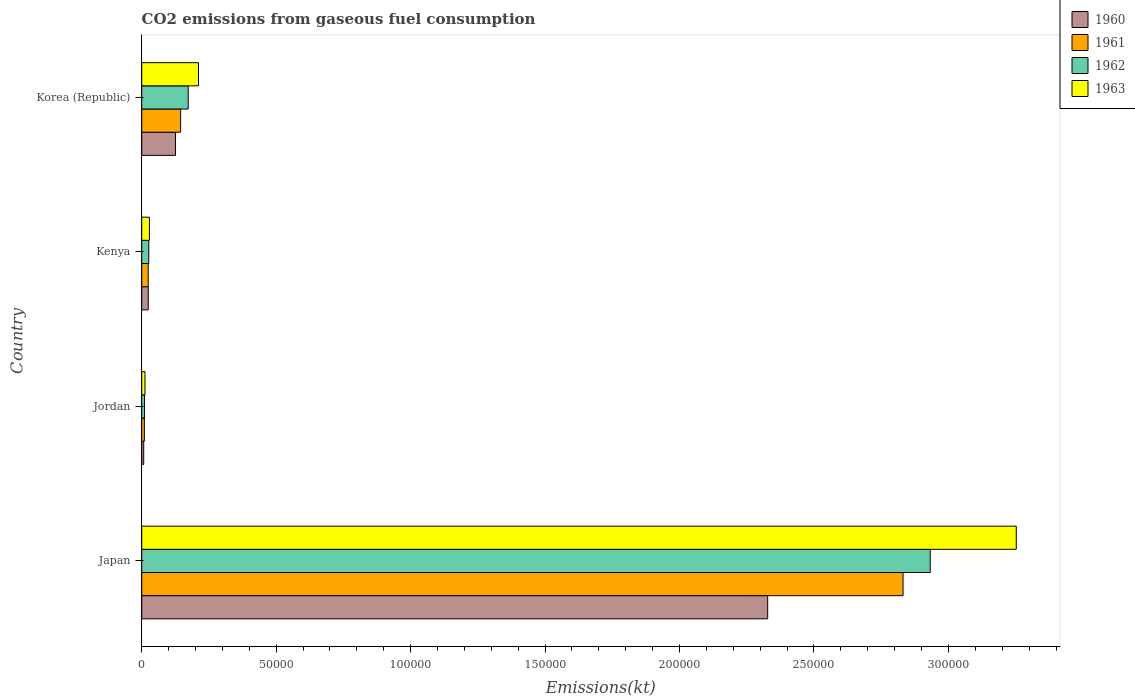How many different coloured bars are there?
Offer a terse response. 4. How many groups of bars are there?
Make the answer very short. 4. How many bars are there on the 1st tick from the bottom?
Ensure brevity in your answer.  4. What is the label of the 2nd group of bars from the top?
Offer a terse response. Kenya. In how many cases, is the number of bars for a given country not equal to the number of legend labels?
Offer a very short reply. 0. What is the amount of CO2 emitted in 1961 in Japan?
Your answer should be very brief. 2.83e+05. Across all countries, what is the maximum amount of CO2 emitted in 1960?
Your answer should be very brief. 2.33e+05. Across all countries, what is the minimum amount of CO2 emitted in 1962?
Provide a succinct answer. 1048.76. In which country was the amount of CO2 emitted in 1960 maximum?
Keep it short and to the point. Japan. In which country was the amount of CO2 emitted in 1962 minimum?
Ensure brevity in your answer.  Jordan. What is the total amount of CO2 emitted in 1960 in the graph?
Your answer should be very brief. 2.49e+05. What is the difference between the amount of CO2 emitted in 1963 in Kenya and that in Korea (Republic)?
Give a very brief answer. -1.82e+04. What is the difference between the amount of CO2 emitted in 1961 in Japan and the amount of CO2 emitted in 1960 in Korea (Republic)?
Your answer should be compact. 2.71e+05. What is the average amount of CO2 emitted in 1960 per country?
Make the answer very short. 6.21e+04. What is the difference between the amount of CO2 emitted in 1962 and amount of CO2 emitted in 1961 in Japan?
Give a very brief answer. 1.01e+04. In how many countries, is the amount of CO2 emitted in 1962 greater than 110000 kt?
Your response must be concise. 1. What is the ratio of the amount of CO2 emitted in 1962 in Jordan to that in Kenya?
Ensure brevity in your answer.  0.4. Is the amount of CO2 emitted in 1961 in Japan less than that in Jordan?
Offer a very short reply. No. What is the difference between the highest and the second highest amount of CO2 emitted in 1960?
Ensure brevity in your answer.  2.20e+05. What is the difference between the highest and the lowest amount of CO2 emitted in 1962?
Your answer should be compact. 2.92e+05. In how many countries, is the amount of CO2 emitted in 1962 greater than the average amount of CO2 emitted in 1962 taken over all countries?
Provide a short and direct response. 1. Is it the case that in every country, the sum of the amount of CO2 emitted in 1961 and amount of CO2 emitted in 1963 is greater than the sum of amount of CO2 emitted in 1962 and amount of CO2 emitted in 1960?
Give a very brief answer. No. Is it the case that in every country, the sum of the amount of CO2 emitted in 1960 and amount of CO2 emitted in 1961 is greater than the amount of CO2 emitted in 1962?
Your answer should be compact. Yes. Are all the bars in the graph horizontal?
Offer a terse response. Yes. What is the difference between two consecutive major ticks on the X-axis?
Your answer should be compact. 5.00e+04. Are the values on the major ticks of X-axis written in scientific E-notation?
Offer a very short reply. No. Does the graph contain any zero values?
Offer a terse response. No. Does the graph contain grids?
Make the answer very short. No. Where does the legend appear in the graph?
Offer a very short reply. Top right. What is the title of the graph?
Offer a terse response. CO2 emissions from gaseous fuel consumption. Does "1969" appear as one of the legend labels in the graph?
Provide a short and direct response. No. What is the label or title of the X-axis?
Your answer should be compact. Emissions(kt). What is the label or title of the Y-axis?
Your answer should be compact. Country. What is the Emissions(kt) in 1960 in Japan?
Offer a very short reply. 2.33e+05. What is the Emissions(kt) of 1961 in Japan?
Ensure brevity in your answer.  2.83e+05. What is the Emissions(kt) in 1962 in Japan?
Keep it short and to the point. 2.93e+05. What is the Emissions(kt) of 1963 in Japan?
Provide a short and direct response. 3.25e+05. What is the Emissions(kt) of 1960 in Jordan?
Your answer should be very brief. 744.4. What is the Emissions(kt) of 1961 in Jordan?
Offer a very short reply. 979.09. What is the Emissions(kt) in 1962 in Jordan?
Provide a succinct answer. 1048.76. What is the Emissions(kt) of 1963 in Jordan?
Your answer should be very brief. 1221.11. What is the Emissions(kt) in 1960 in Kenya?
Offer a terse response. 2427.55. What is the Emissions(kt) in 1961 in Kenya?
Your answer should be very brief. 2401.89. What is the Emissions(kt) in 1962 in Kenya?
Your answer should be very brief. 2625.57. What is the Emissions(kt) of 1963 in Kenya?
Offer a very short reply. 2856.59. What is the Emissions(kt) of 1960 in Korea (Republic)?
Ensure brevity in your answer.  1.26e+04. What is the Emissions(kt) in 1961 in Korea (Republic)?
Give a very brief answer. 1.45e+04. What is the Emissions(kt) in 1962 in Korea (Republic)?
Ensure brevity in your answer.  1.73e+04. What is the Emissions(kt) of 1963 in Korea (Republic)?
Provide a short and direct response. 2.11e+04. Across all countries, what is the maximum Emissions(kt) in 1960?
Offer a terse response. 2.33e+05. Across all countries, what is the maximum Emissions(kt) of 1961?
Keep it short and to the point. 2.83e+05. Across all countries, what is the maximum Emissions(kt) in 1962?
Provide a succinct answer. 2.93e+05. Across all countries, what is the maximum Emissions(kt) in 1963?
Make the answer very short. 3.25e+05. Across all countries, what is the minimum Emissions(kt) of 1960?
Offer a very short reply. 744.4. Across all countries, what is the minimum Emissions(kt) in 1961?
Offer a very short reply. 979.09. Across all countries, what is the minimum Emissions(kt) in 1962?
Provide a succinct answer. 1048.76. Across all countries, what is the minimum Emissions(kt) of 1963?
Give a very brief answer. 1221.11. What is the total Emissions(kt) in 1960 in the graph?
Your response must be concise. 2.49e+05. What is the total Emissions(kt) of 1961 in the graph?
Provide a short and direct response. 3.01e+05. What is the total Emissions(kt) of 1962 in the graph?
Your response must be concise. 3.14e+05. What is the total Emissions(kt) in 1963 in the graph?
Offer a terse response. 3.50e+05. What is the difference between the Emissions(kt) in 1960 in Japan and that in Jordan?
Provide a succinct answer. 2.32e+05. What is the difference between the Emissions(kt) of 1961 in Japan and that in Jordan?
Ensure brevity in your answer.  2.82e+05. What is the difference between the Emissions(kt) in 1962 in Japan and that in Jordan?
Keep it short and to the point. 2.92e+05. What is the difference between the Emissions(kt) in 1963 in Japan and that in Jordan?
Offer a very short reply. 3.24e+05. What is the difference between the Emissions(kt) of 1960 in Japan and that in Kenya?
Offer a terse response. 2.30e+05. What is the difference between the Emissions(kt) of 1961 in Japan and that in Kenya?
Offer a very short reply. 2.81e+05. What is the difference between the Emissions(kt) in 1962 in Japan and that in Kenya?
Offer a very short reply. 2.91e+05. What is the difference between the Emissions(kt) of 1963 in Japan and that in Kenya?
Your response must be concise. 3.22e+05. What is the difference between the Emissions(kt) in 1960 in Japan and that in Korea (Republic)?
Give a very brief answer. 2.20e+05. What is the difference between the Emissions(kt) of 1961 in Japan and that in Korea (Republic)?
Keep it short and to the point. 2.69e+05. What is the difference between the Emissions(kt) of 1962 in Japan and that in Korea (Republic)?
Make the answer very short. 2.76e+05. What is the difference between the Emissions(kt) in 1963 in Japan and that in Korea (Republic)?
Provide a succinct answer. 3.04e+05. What is the difference between the Emissions(kt) of 1960 in Jordan and that in Kenya?
Offer a terse response. -1683.15. What is the difference between the Emissions(kt) of 1961 in Jordan and that in Kenya?
Provide a short and direct response. -1422.8. What is the difference between the Emissions(kt) of 1962 in Jordan and that in Kenya?
Make the answer very short. -1576.81. What is the difference between the Emissions(kt) of 1963 in Jordan and that in Kenya?
Your answer should be compact. -1635.48. What is the difference between the Emissions(kt) in 1960 in Jordan and that in Korea (Republic)?
Give a very brief answer. -1.18e+04. What is the difference between the Emissions(kt) of 1961 in Jordan and that in Korea (Republic)?
Your response must be concise. -1.35e+04. What is the difference between the Emissions(kt) in 1962 in Jordan and that in Korea (Republic)?
Your response must be concise. -1.62e+04. What is the difference between the Emissions(kt) in 1963 in Jordan and that in Korea (Republic)?
Offer a very short reply. -1.99e+04. What is the difference between the Emissions(kt) in 1960 in Kenya and that in Korea (Republic)?
Provide a short and direct response. -1.01e+04. What is the difference between the Emissions(kt) in 1961 in Kenya and that in Korea (Republic)?
Offer a very short reply. -1.21e+04. What is the difference between the Emissions(kt) of 1962 in Kenya and that in Korea (Republic)?
Make the answer very short. -1.47e+04. What is the difference between the Emissions(kt) in 1963 in Kenya and that in Korea (Republic)?
Ensure brevity in your answer.  -1.82e+04. What is the difference between the Emissions(kt) in 1960 in Japan and the Emissions(kt) in 1961 in Jordan?
Keep it short and to the point. 2.32e+05. What is the difference between the Emissions(kt) of 1960 in Japan and the Emissions(kt) of 1962 in Jordan?
Keep it short and to the point. 2.32e+05. What is the difference between the Emissions(kt) of 1960 in Japan and the Emissions(kt) of 1963 in Jordan?
Give a very brief answer. 2.32e+05. What is the difference between the Emissions(kt) in 1961 in Japan and the Emissions(kt) in 1962 in Jordan?
Give a very brief answer. 2.82e+05. What is the difference between the Emissions(kt) in 1961 in Japan and the Emissions(kt) in 1963 in Jordan?
Your answer should be very brief. 2.82e+05. What is the difference between the Emissions(kt) in 1962 in Japan and the Emissions(kt) in 1963 in Jordan?
Ensure brevity in your answer.  2.92e+05. What is the difference between the Emissions(kt) in 1960 in Japan and the Emissions(kt) in 1961 in Kenya?
Offer a very short reply. 2.30e+05. What is the difference between the Emissions(kt) in 1960 in Japan and the Emissions(kt) in 1962 in Kenya?
Your answer should be compact. 2.30e+05. What is the difference between the Emissions(kt) in 1960 in Japan and the Emissions(kt) in 1963 in Kenya?
Provide a short and direct response. 2.30e+05. What is the difference between the Emissions(kt) in 1961 in Japan and the Emissions(kt) in 1962 in Kenya?
Offer a terse response. 2.80e+05. What is the difference between the Emissions(kt) in 1961 in Japan and the Emissions(kt) in 1963 in Kenya?
Your response must be concise. 2.80e+05. What is the difference between the Emissions(kt) in 1962 in Japan and the Emissions(kt) in 1963 in Kenya?
Your response must be concise. 2.90e+05. What is the difference between the Emissions(kt) of 1960 in Japan and the Emissions(kt) of 1961 in Korea (Republic)?
Your response must be concise. 2.18e+05. What is the difference between the Emissions(kt) in 1960 in Japan and the Emissions(kt) in 1962 in Korea (Republic)?
Provide a short and direct response. 2.16e+05. What is the difference between the Emissions(kt) in 1960 in Japan and the Emissions(kt) in 1963 in Korea (Republic)?
Provide a short and direct response. 2.12e+05. What is the difference between the Emissions(kt) in 1961 in Japan and the Emissions(kt) in 1962 in Korea (Republic)?
Your answer should be very brief. 2.66e+05. What is the difference between the Emissions(kt) in 1961 in Japan and the Emissions(kt) in 1963 in Korea (Republic)?
Your answer should be very brief. 2.62e+05. What is the difference between the Emissions(kt) of 1962 in Japan and the Emissions(kt) of 1963 in Korea (Republic)?
Make the answer very short. 2.72e+05. What is the difference between the Emissions(kt) in 1960 in Jordan and the Emissions(kt) in 1961 in Kenya?
Your answer should be very brief. -1657.48. What is the difference between the Emissions(kt) of 1960 in Jordan and the Emissions(kt) of 1962 in Kenya?
Offer a very short reply. -1881.17. What is the difference between the Emissions(kt) in 1960 in Jordan and the Emissions(kt) in 1963 in Kenya?
Provide a succinct answer. -2112.19. What is the difference between the Emissions(kt) in 1961 in Jordan and the Emissions(kt) in 1962 in Kenya?
Offer a very short reply. -1646.48. What is the difference between the Emissions(kt) in 1961 in Jordan and the Emissions(kt) in 1963 in Kenya?
Your answer should be very brief. -1877.5. What is the difference between the Emissions(kt) in 1962 in Jordan and the Emissions(kt) in 1963 in Kenya?
Your response must be concise. -1807.83. What is the difference between the Emissions(kt) in 1960 in Jordan and the Emissions(kt) in 1961 in Korea (Republic)?
Ensure brevity in your answer.  -1.37e+04. What is the difference between the Emissions(kt) in 1960 in Jordan and the Emissions(kt) in 1962 in Korea (Republic)?
Provide a succinct answer. -1.65e+04. What is the difference between the Emissions(kt) in 1960 in Jordan and the Emissions(kt) in 1963 in Korea (Republic)?
Keep it short and to the point. -2.04e+04. What is the difference between the Emissions(kt) of 1961 in Jordan and the Emissions(kt) of 1962 in Korea (Republic)?
Make the answer very short. -1.63e+04. What is the difference between the Emissions(kt) in 1961 in Jordan and the Emissions(kt) in 1963 in Korea (Republic)?
Make the answer very short. -2.01e+04. What is the difference between the Emissions(kt) of 1962 in Jordan and the Emissions(kt) of 1963 in Korea (Republic)?
Give a very brief answer. -2.01e+04. What is the difference between the Emissions(kt) of 1960 in Kenya and the Emissions(kt) of 1961 in Korea (Republic)?
Your answer should be very brief. -1.20e+04. What is the difference between the Emissions(kt) of 1960 in Kenya and the Emissions(kt) of 1962 in Korea (Republic)?
Offer a very short reply. -1.49e+04. What is the difference between the Emissions(kt) of 1960 in Kenya and the Emissions(kt) of 1963 in Korea (Republic)?
Your answer should be very brief. -1.87e+04. What is the difference between the Emissions(kt) in 1961 in Kenya and the Emissions(kt) in 1962 in Korea (Republic)?
Provide a succinct answer. -1.49e+04. What is the difference between the Emissions(kt) of 1961 in Kenya and the Emissions(kt) of 1963 in Korea (Republic)?
Your answer should be compact. -1.87e+04. What is the difference between the Emissions(kt) in 1962 in Kenya and the Emissions(kt) in 1963 in Korea (Republic)?
Offer a terse response. -1.85e+04. What is the average Emissions(kt) in 1960 per country?
Your response must be concise. 6.21e+04. What is the average Emissions(kt) in 1961 per country?
Your answer should be compact. 7.52e+04. What is the average Emissions(kt) in 1962 per country?
Make the answer very short. 7.85e+04. What is the average Emissions(kt) in 1963 per country?
Give a very brief answer. 8.76e+04. What is the difference between the Emissions(kt) in 1960 and Emissions(kt) in 1961 in Japan?
Provide a short and direct response. -5.03e+04. What is the difference between the Emissions(kt) in 1960 and Emissions(kt) in 1962 in Japan?
Offer a very short reply. -6.04e+04. What is the difference between the Emissions(kt) in 1960 and Emissions(kt) in 1963 in Japan?
Ensure brevity in your answer.  -9.24e+04. What is the difference between the Emissions(kt) of 1961 and Emissions(kt) of 1962 in Japan?
Offer a terse response. -1.01e+04. What is the difference between the Emissions(kt) of 1961 and Emissions(kt) of 1963 in Japan?
Provide a short and direct response. -4.21e+04. What is the difference between the Emissions(kt) of 1962 and Emissions(kt) of 1963 in Japan?
Make the answer very short. -3.20e+04. What is the difference between the Emissions(kt) of 1960 and Emissions(kt) of 1961 in Jordan?
Make the answer very short. -234.69. What is the difference between the Emissions(kt) of 1960 and Emissions(kt) of 1962 in Jordan?
Keep it short and to the point. -304.36. What is the difference between the Emissions(kt) in 1960 and Emissions(kt) in 1963 in Jordan?
Your answer should be very brief. -476.71. What is the difference between the Emissions(kt) of 1961 and Emissions(kt) of 1962 in Jordan?
Provide a succinct answer. -69.67. What is the difference between the Emissions(kt) of 1961 and Emissions(kt) of 1963 in Jordan?
Make the answer very short. -242.02. What is the difference between the Emissions(kt) in 1962 and Emissions(kt) in 1963 in Jordan?
Your answer should be very brief. -172.35. What is the difference between the Emissions(kt) in 1960 and Emissions(kt) in 1961 in Kenya?
Give a very brief answer. 25.67. What is the difference between the Emissions(kt) in 1960 and Emissions(kt) in 1962 in Kenya?
Offer a terse response. -198.02. What is the difference between the Emissions(kt) of 1960 and Emissions(kt) of 1963 in Kenya?
Provide a succinct answer. -429.04. What is the difference between the Emissions(kt) of 1961 and Emissions(kt) of 1962 in Kenya?
Make the answer very short. -223.69. What is the difference between the Emissions(kt) in 1961 and Emissions(kt) in 1963 in Kenya?
Your answer should be compact. -454.71. What is the difference between the Emissions(kt) of 1962 and Emissions(kt) of 1963 in Kenya?
Offer a terse response. -231.02. What is the difference between the Emissions(kt) in 1960 and Emissions(kt) in 1961 in Korea (Republic)?
Make the answer very short. -1910.51. What is the difference between the Emissions(kt) in 1960 and Emissions(kt) in 1962 in Korea (Republic)?
Provide a short and direct response. -4726.76. What is the difference between the Emissions(kt) of 1960 and Emissions(kt) of 1963 in Korea (Republic)?
Provide a short and direct response. -8551.44. What is the difference between the Emissions(kt) in 1961 and Emissions(kt) in 1962 in Korea (Republic)?
Your response must be concise. -2816.26. What is the difference between the Emissions(kt) in 1961 and Emissions(kt) in 1963 in Korea (Republic)?
Ensure brevity in your answer.  -6640.94. What is the difference between the Emissions(kt) in 1962 and Emissions(kt) in 1963 in Korea (Republic)?
Ensure brevity in your answer.  -3824.68. What is the ratio of the Emissions(kt) of 1960 in Japan to that in Jordan?
Your answer should be compact. 312.71. What is the ratio of the Emissions(kt) in 1961 in Japan to that in Jordan?
Make the answer very short. 289.16. What is the ratio of the Emissions(kt) of 1962 in Japan to that in Jordan?
Your response must be concise. 279.59. What is the ratio of the Emissions(kt) in 1963 in Japan to that in Jordan?
Keep it short and to the point. 266.33. What is the ratio of the Emissions(kt) of 1960 in Japan to that in Kenya?
Your response must be concise. 95.89. What is the ratio of the Emissions(kt) of 1961 in Japan to that in Kenya?
Your response must be concise. 117.87. What is the ratio of the Emissions(kt) of 1962 in Japan to that in Kenya?
Provide a short and direct response. 111.68. What is the ratio of the Emissions(kt) in 1963 in Japan to that in Kenya?
Give a very brief answer. 113.85. What is the ratio of the Emissions(kt) in 1960 in Japan to that in Korea (Republic)?
Keep it short and to the point. 18.55. What is the ratio of the Emissions(kt) of 1961 in Japan to that in Korea (Republic)?
Your answer should be compact. 19.58. What is the ratio of the Emissions(kt) in 1962 in Japan to that in Korea (Republic)?
Make the answer very short. 16.97. What is the ratio of the Emissions(kt) of 1963 in Japan to that in Korea (Republic)?
Give a very brief answer. 15.41. What is the ratio of the Emissions(kt) in 1960 in Jordan to that in Kenya?
Provide a short and direct response. 0.31. What is the ratio of the Emissions(kt) in 1961 in Jordan to that in Kenya?
Offer a terse response. 0.41. What is the ratio of the Emissions(kt) in 1962 in Jordan to that in Kenya?
Ensure brevity in your answer.  0.4. What is the ratio of the Emissions(kt) in 1963 in Jordan to that in Kenya?
Your answer should be compact. 0.43. What is the ratio of the Emissions(kt) in 1960 in Jordan to that in Korea (Republic)?
Your answer should be very brief. 0.06. What is the ratio of the Emissions(kt) in 1961 in Jordan to that in Korea (Republic)?
Give a very brief answer. 0.07. What is the ratio of the Emissions(kt) of 1962 in Jordan to that in Korea (Republic)?
Ensure brevity in your answer.  0.06. What is the ratio of the Emissions(kt) in 1963 in Jordan to that in Korea (Republic)?
Provide a succinct answer. 0.06. What is the ratio of the Emissions(kt) in 1960 in Kenya to that in Korea (Republic)?
Give a very brief answer. 0.19. What is the ratio of the Emissions(kt) of 1961 in Kenya to that in Korea (Republic)?
Keep it short and to the point. 0.17. What is the ratio of the Emissions(kt) in 1962 in Kenya to that in Korea (Republic)?
Provide a succinct answer. 0.15. What is the ratio of the Emissions(kt) of 1963 in Kenya to that in Korea (Republic)?
Your response must be concise. 0.14. What is the difference between the highest and the second highest Emissions(kt) in 1960?
Your answer should be compact. 2.20e+05. What is the difference between the highest and the second highest Emissions(kt) of 1961?
Offer a very short reply. 2.69e+05. What is the difference between the highest and the second highest Emissions(kt) of 1962?
Keep it short and to the point. 2.76e+05. What is the difference between the highest and the second highest Emissions(kt) of 1963?
Your answer should be compact. 3.04e+05. What is the difference between the highest and the lowest Emissions(kt) in 1960?
Ensure brevity in your answer.  2.32e+05. What is the difference between the highest and the lowest Emissions(kt) of 1961?
Give a very brief answer. 2.82e+05. What is the difference between the highest and the lowest Emissions(kt) of 1962?
Provide a short and direct response. 2.92e+05. What is the difference between the highest and the lowest Emissions(kt) of 1963?
Provide a succinct answer. 3.24e+05. 